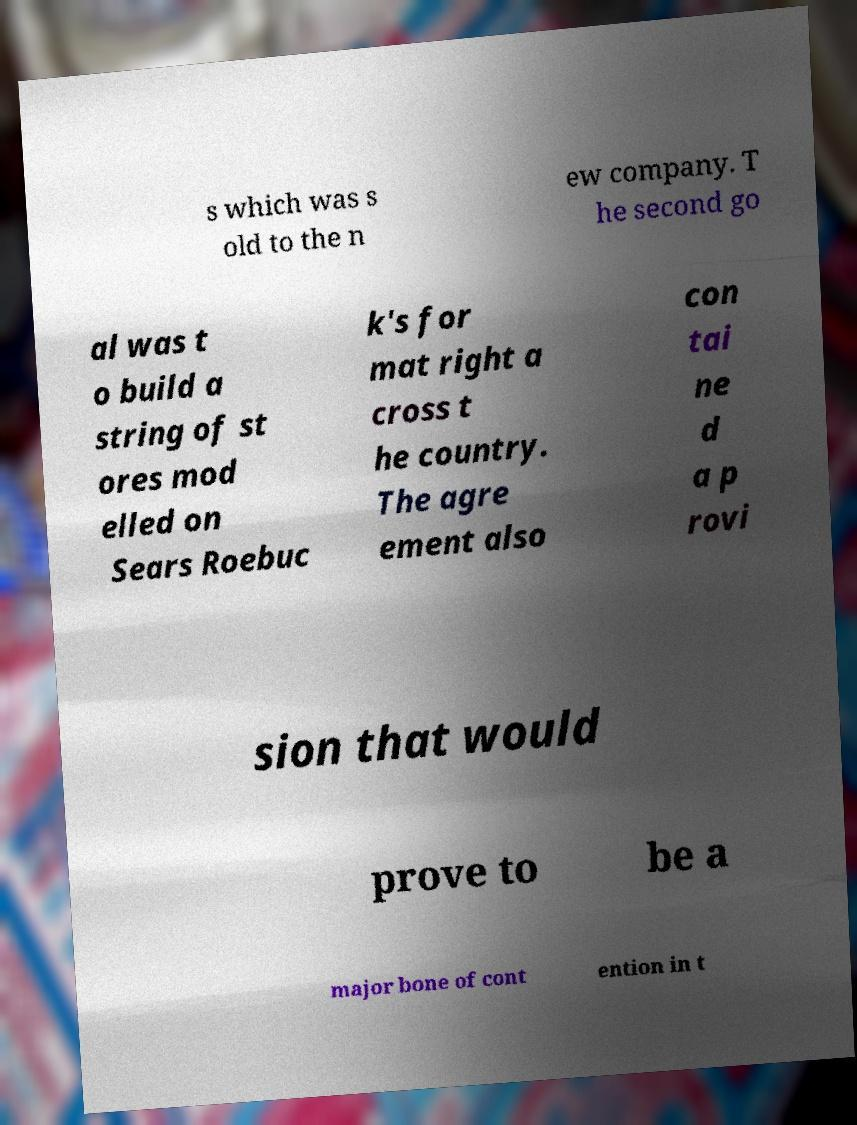For documentation purposes, I need the text within this image transcribed. Could you provide that? s which was s old to the n ew company. T he second go al was t o build a string of st ores mod elled on Sears Roebuc k's for mat right a cross t he country. The agre ement also con tai ne d a p rovi sion that would prove to be a major bone of cont ention in t 